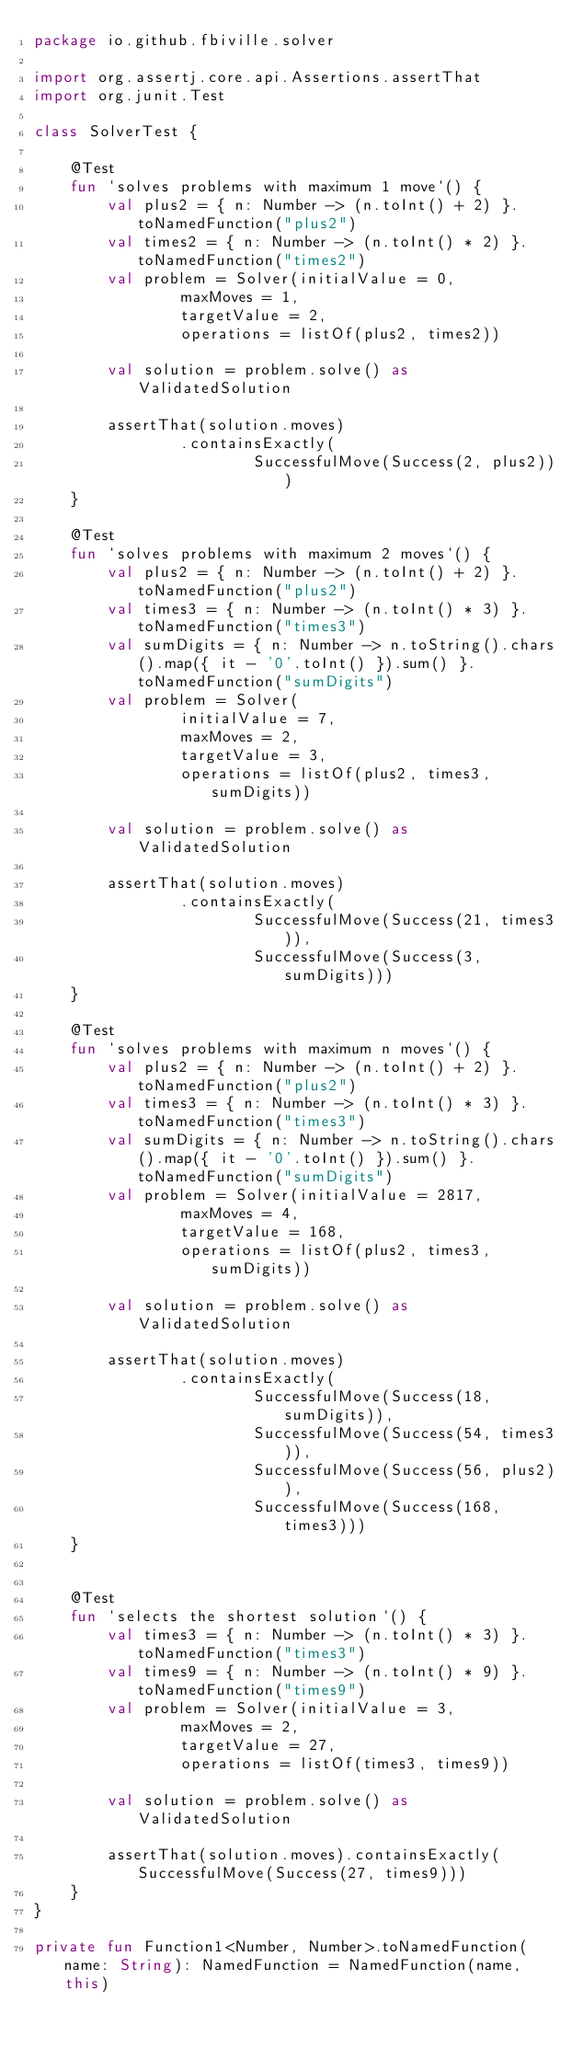<code> <loc_0><loc_0><loc_500><loc_500><_Kotlin_>package io.github.fbiville.solver

import org.assertj.core.api.Assertions.assertThat
import org.junit.Test

class SolverTest {

    @Test
    fun `solves problems with maximum 1 move`() {
        val plus2 = { n: Number -> (n.toInt() + 2) }.toNamedFunction("plus2")
        val times2 = { n: Number -> (n.toInt() * 2) }.toNamedFunction("times2")
        val problem = Solver(initialValue = 0,
                maxMoves = 1,
                targetValue = 2,
                operations = listOf(plus2, times2))

        val solution = problem.solve() as ValidatedSolution

        assertThat(solution.moves)
                .containsExactly(
                        SuccessfulMove(Success(2, plus2)))
    }

    @Test
    fun `solves problems with maximum 2 moves`() {
        val plus2 = { n: Number -> (n.toInt() + 2) }.toNamedFunction("plus2")
        val times3 = { n: Number -> (n.toInt() * 3) }.toNamedFunction("times3")
        val sumDigits = { n: Number -> n.toString().chars().map({ it - '0'.toInt() }).sum() }.toNamedFunction("sumDigits")
        val problem = Solver(
                initialValue = 7,
                maxMoves = 2,
                targetValue = 3,
                operations = listOf(plus2, times3, sumDigits))

        val solution = problem.solve() as ValidatedSolution

        assertThat(solution.moves)
                .containsExactly(
                        SuccessfulMove(Success(21, times3)),
                        SuccessfulMove(Success(3, sumDigits)))
    }

    @Test
    fun `solves problems with maximum n moves`() {
        val plus2 = { n: Number -> (n.toInt() + 2) }.toNamedFunction("plus2")
        val times3 = { n: Number -> (n.toInt() * 3) }.toNamedFunction("times3")
        val sumDigits = { n: Number -> n.toString().chars().map({ it - '0'.toInt() }).sum() }.toNamedFunction("sumDigits")
        val problem = Solver(initialValue = 2817,
                maxMoves = 4,
                targetValue = 168,
                operations = listOf(plus2, times3, sumDigits))

        val solution = problem.solve() as ValidatedSolution

        assertThat(solution.moves)
                .containsExactly(
                        SuccessfulMove(Success(18, sumDigits)),
                        SuccessfulMove(Success(54, times3)),
                        SuccessfulMove(Success(56, plus2)),
                        SuccessfulMove(Success(168, times3)))
    }


    @Test
    fun `selects the shortest solution`() {
        val times3 = { n: Number -> (n.toInt() * 3) }.toNamedFunction("times3")
        val times9 = { n: Number -> (n.toInt() * 9) }.toNamedFunction("times9")
        val problem = Solver(initialValue = 3,
                maxMoves = 2,
                targetValue = 27,
                operations = listOf(times3, times9))
        
        val solution = problem.solve() as ValidatedSolution

        assertThat(solution.moves).containsExactly(SuccessfulMove(Success(27, times9)))
    }
}

private fun Function1<Number, Number>.toNamedFunction(name: String): NamedFunction = NamedFunction(name, this)
</code> 